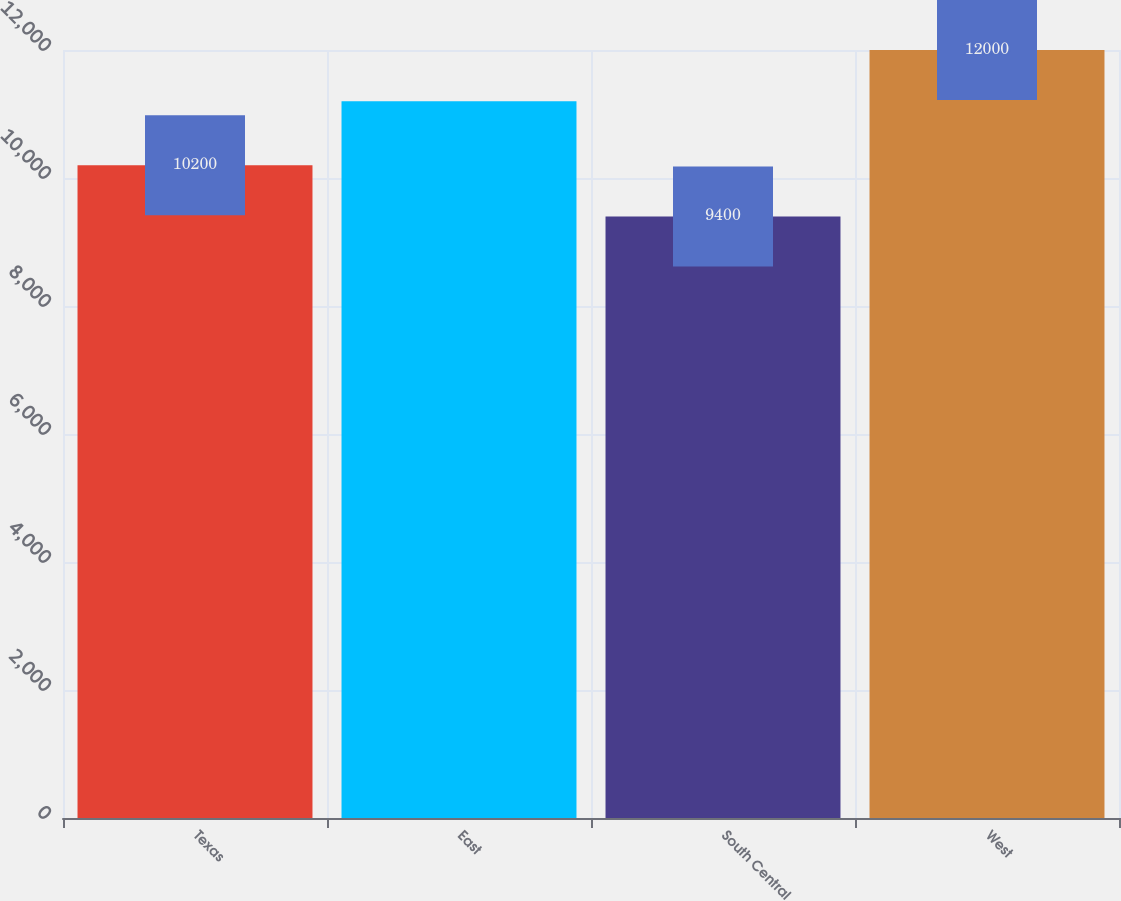Convert chart to OTSL. <chart><loc_0><loc_0><loc_500><loc_500><bar_chart><fcel>Texas<fcel>East<fcel>South Central<fcel>West<nl><fcel>10200<fcel>11200<fcel>9400<fcel>12000<nl></chart> 